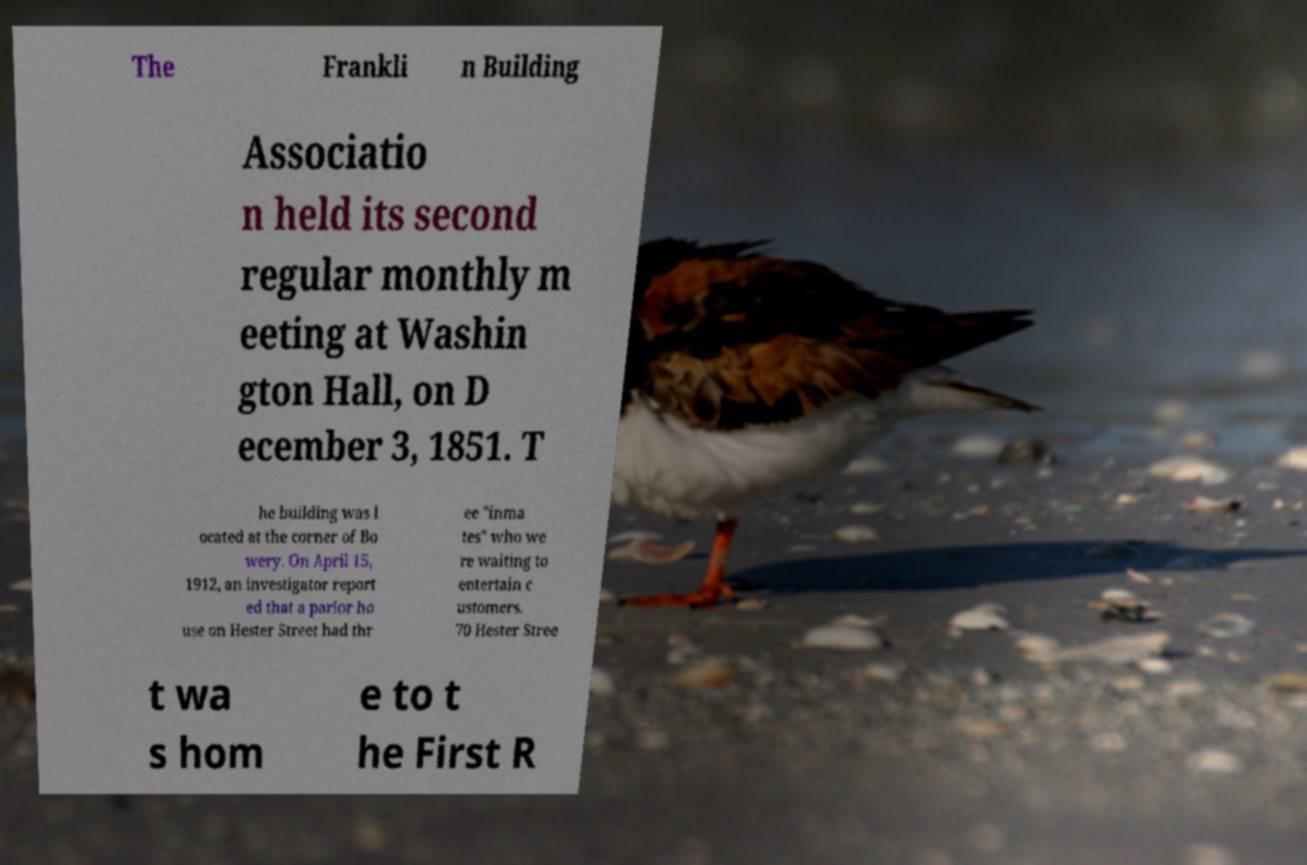I need the written content from this picture converted into text. Can you do that? The Frankli n Building Associatio n held its second regular monthly m eeting at Washin gton Hall, on D ecember 3, 1851. T he building was l ocated at the corner of Bo wery. On April 15, 1912, an investigator report ed that a parlor ho use on Hester Street had thr ee "inma tes" who we re waiting to entertain c ustomers. 70 Hester Stree t wa s hom e to t he First R 